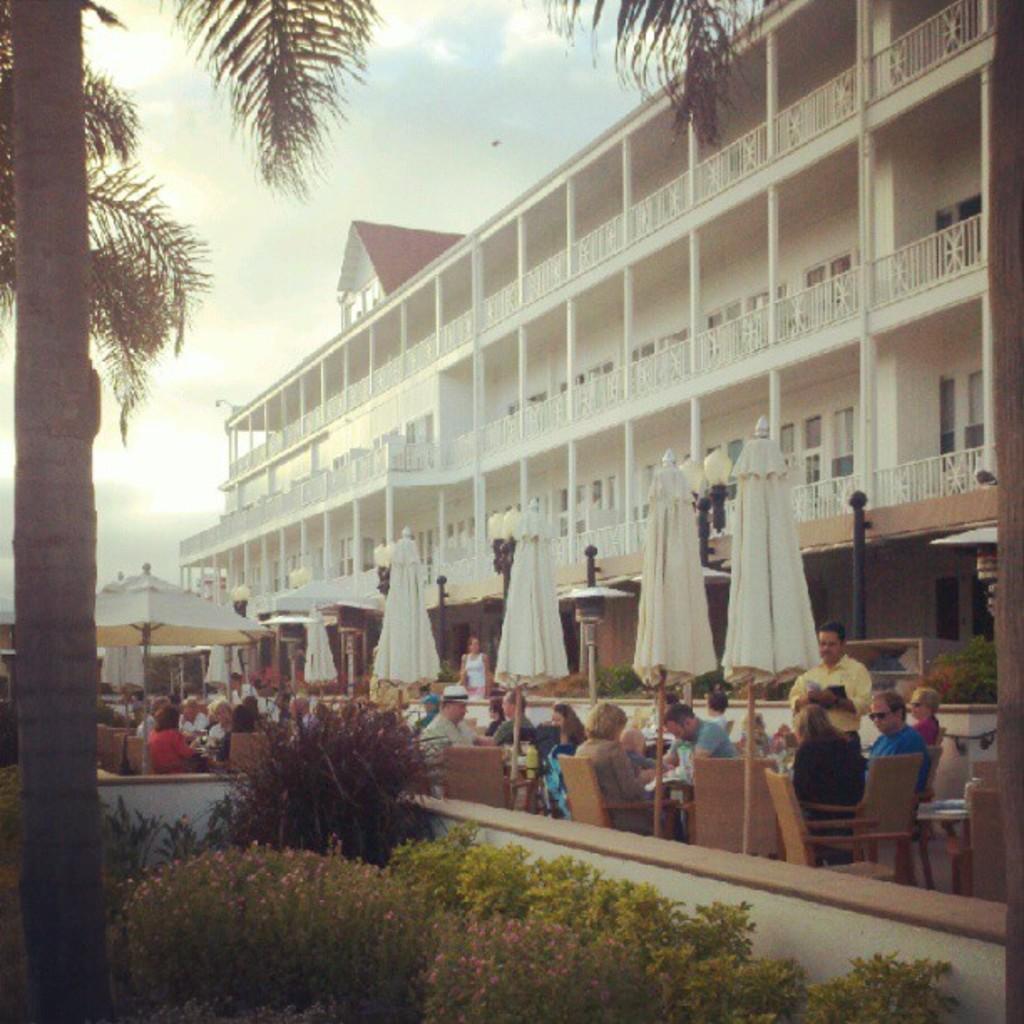Can you describe this image briefly? This image is taken outdoors. At the top of the image there is a sky with clouds. At the bottom of the image there are a few plants. On the left side of the image there is a tree. In the middle of the image there are a few umbrellas and a few people are sitting on the chairs and a few are standing. On the right side of the image there is a building with walls, windows, pillars, railings and doors. 